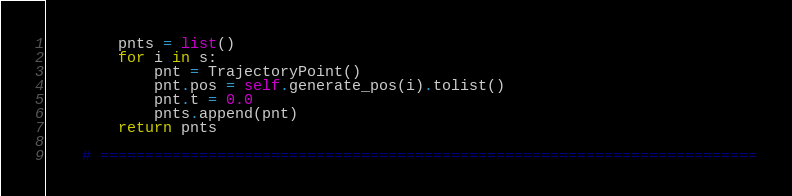Convert code to text. <code><loc_0><loc_0><loc_500><loc_500><_Python_>
        pnts = list()
        for i in s:
            pnt = TrajectoryPoint()
            pnt.pos = self.generate_pos(i).tolist()
            pnt.t = 0.0
            pnts.append(pnt)
        return pnts

    # =========================================================================</code> 